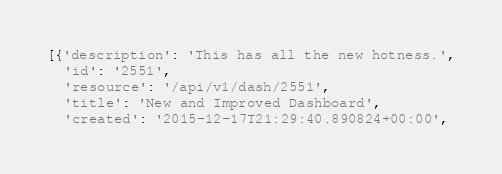Convert code to text. <code><loc_0><loc_0><loc_500><loc_500><_Python_>[{'description': 'This has all the new hotness.',
  'id': '2551',
  'resource': '/api/v1/dash/2551',
  'title': 'New and Improved Dashboard',
  'created': '2015-12-17T21:29:40.890824+00:00',</code> 